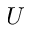<formula> <loc_0><loc_0><loc_500><loc_500>U</formula> 